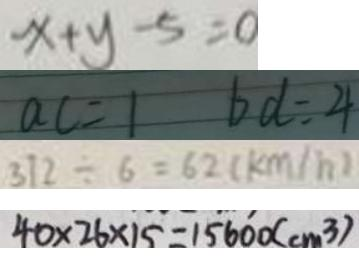Convert formula to latex. <formula><loc_0><loc_0><loc_500><loc_500>x + y - 5 = 0 
 a c = 1 b d = 4 
 3 7 2 \div 6 = 6 2 ( k m / h ) 
 4 0 \times 2 6 \times 1 5 = 1 5 6 0 0 ( c m ^ { 3 } )</formula> 